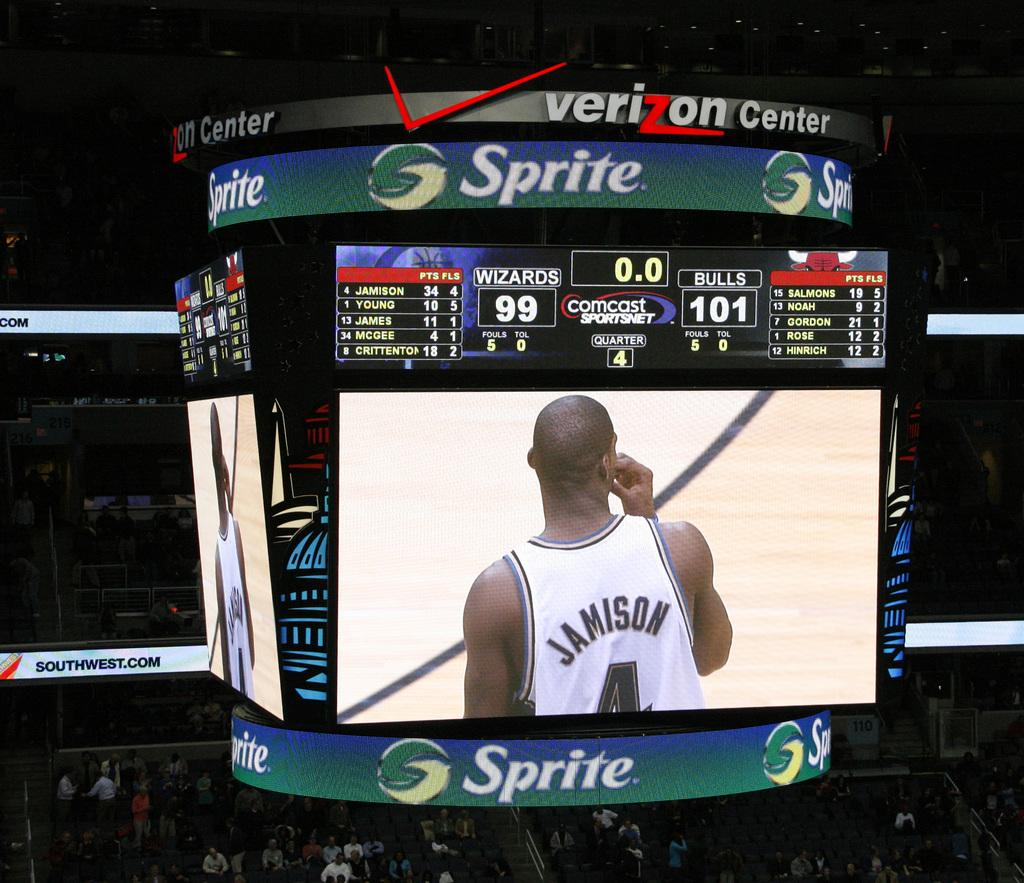Provide a one-sentence caption for the provided image. The scoreboard at the Verizon Center is partially sponsored by Sprite. 